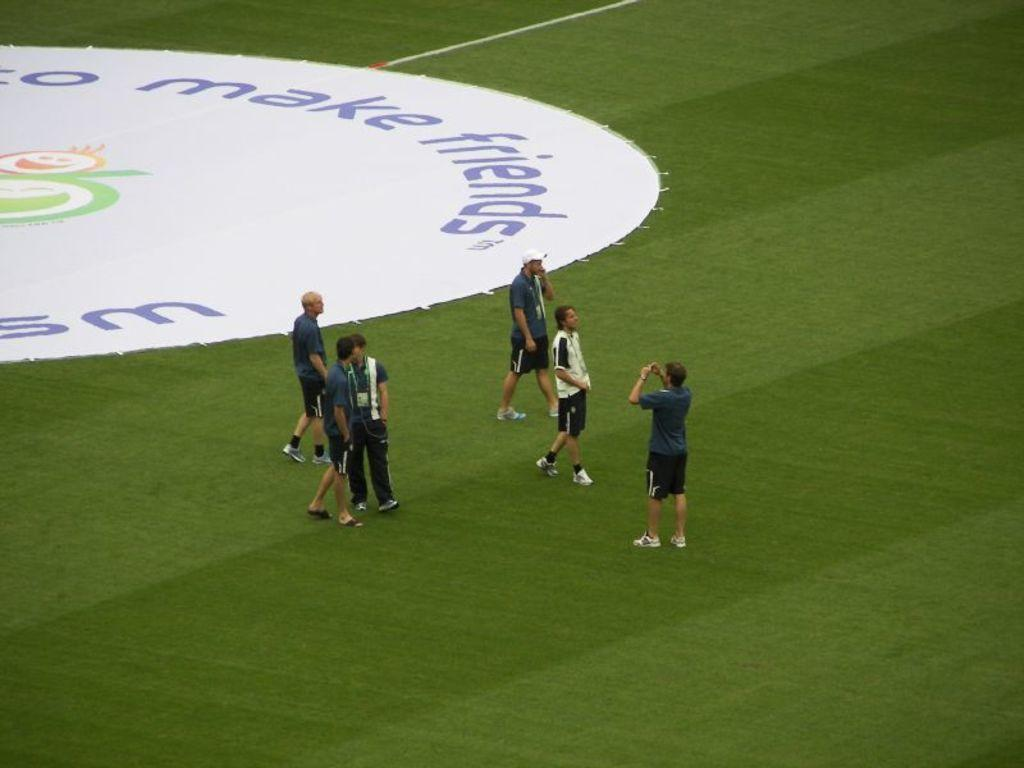<image>
Render a clear and concise summary of the photo. A group of people standing on a field with make friends written on it. 